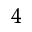Convert formula to latex. <formula><loc_0><loc_0><loc_500><loc_500>^ { 4 }</formula> 